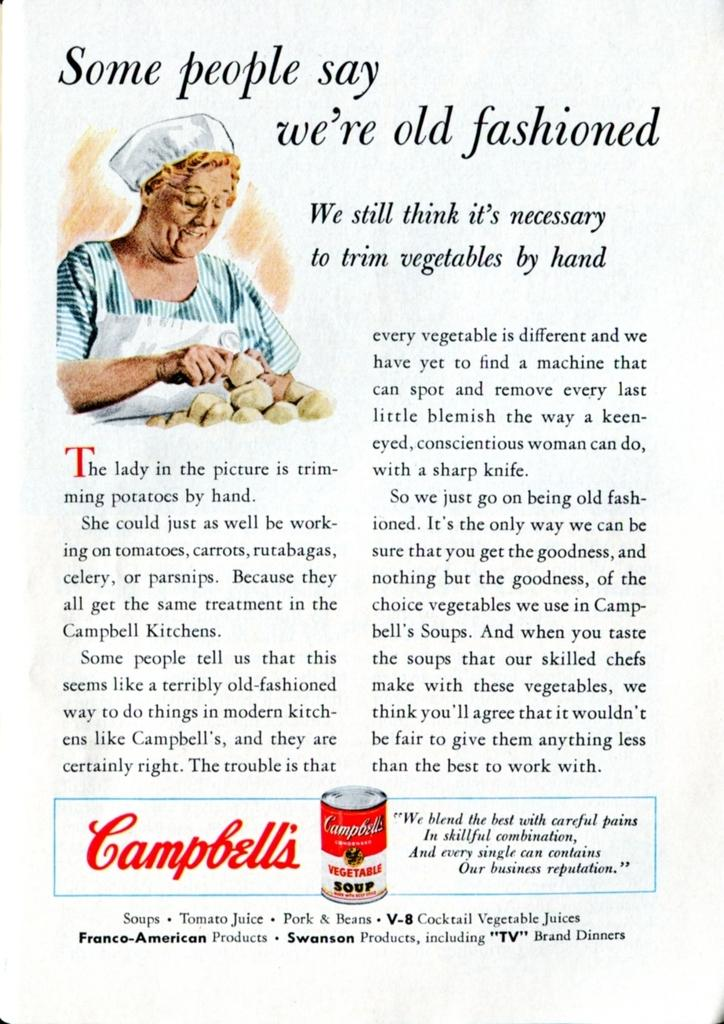What is the person in the image holding? There is an object being held by the person in the image. Can you describe the clothing worn by the person in the image? The person is wearing a blue and white color dress. What else can be seen in the image besides the person and the object they are holding? There is text or writing visible in the image. What type of skin condition is visible on the person's face in the image? There is no skin condition visible on the person's face in the image. What prose or poetry is being recited by the person in the image? The image does not depict the person reciting any prose or poetry. 